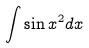Convert formula to latex. <formula><loc_0><loc_0><loc_500><loc_500>\int \sin x ^ { 2 } d x</formula> 